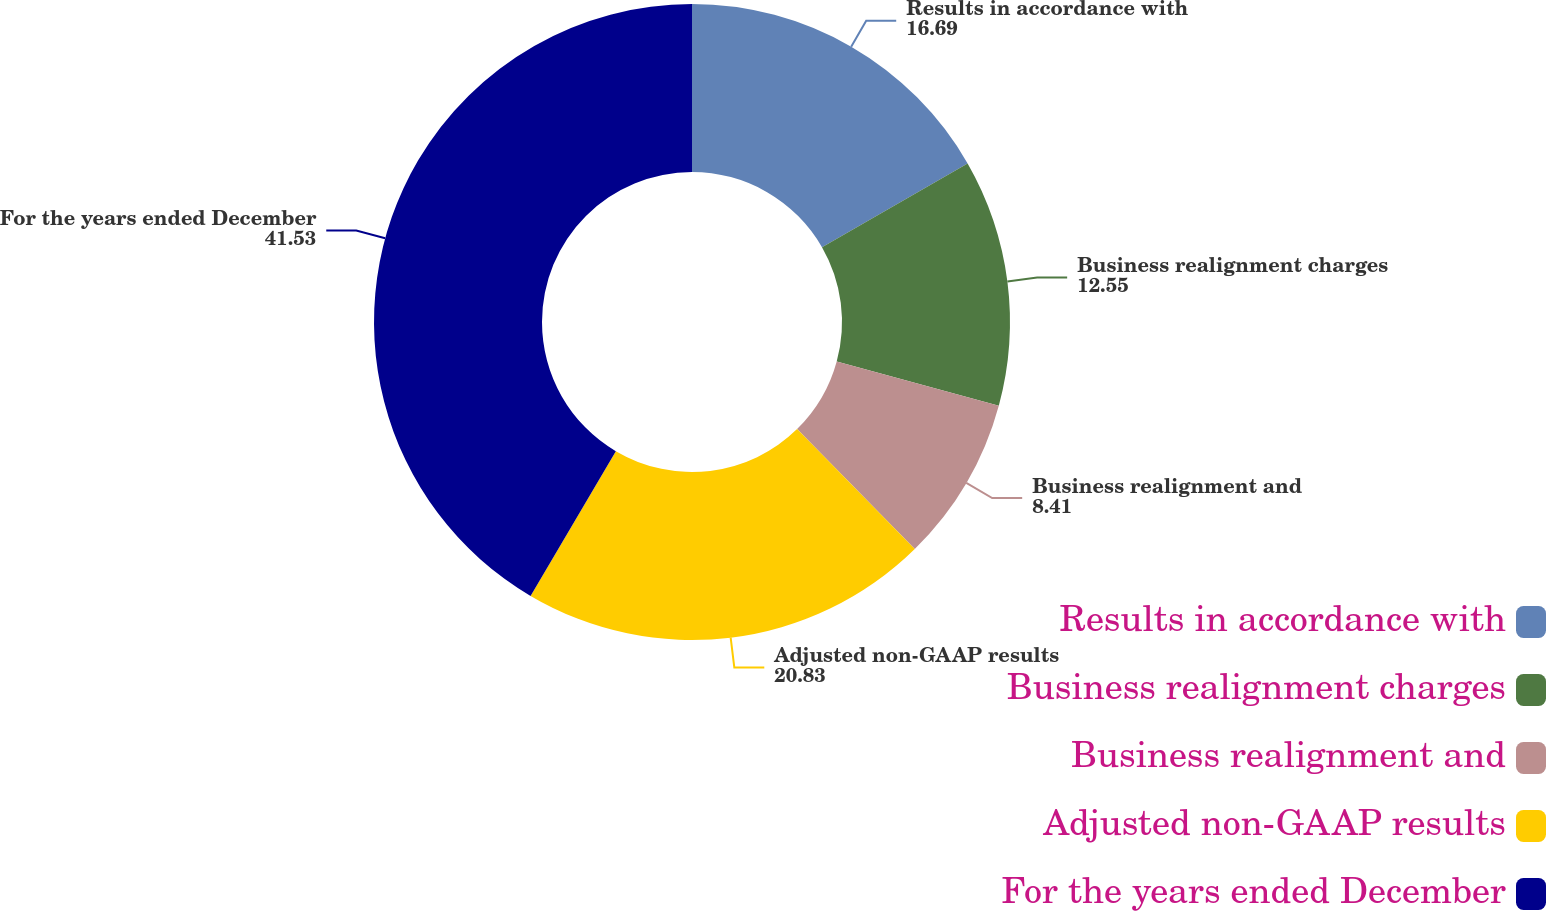<chart> <loc_0><loc_0><loc_500><loc_500><pie_chart><fcel>Results in accordance with<fcel>Business realignment charges<fcel>Business realignment and<fcel>Adjusted non-GAAP results<fcel>For the years ended December<nl><fcel>16.69%<fcel>12.55%<fcel>8.41%<fcel>20.83%<fcel>41.53%<nl></chart> 